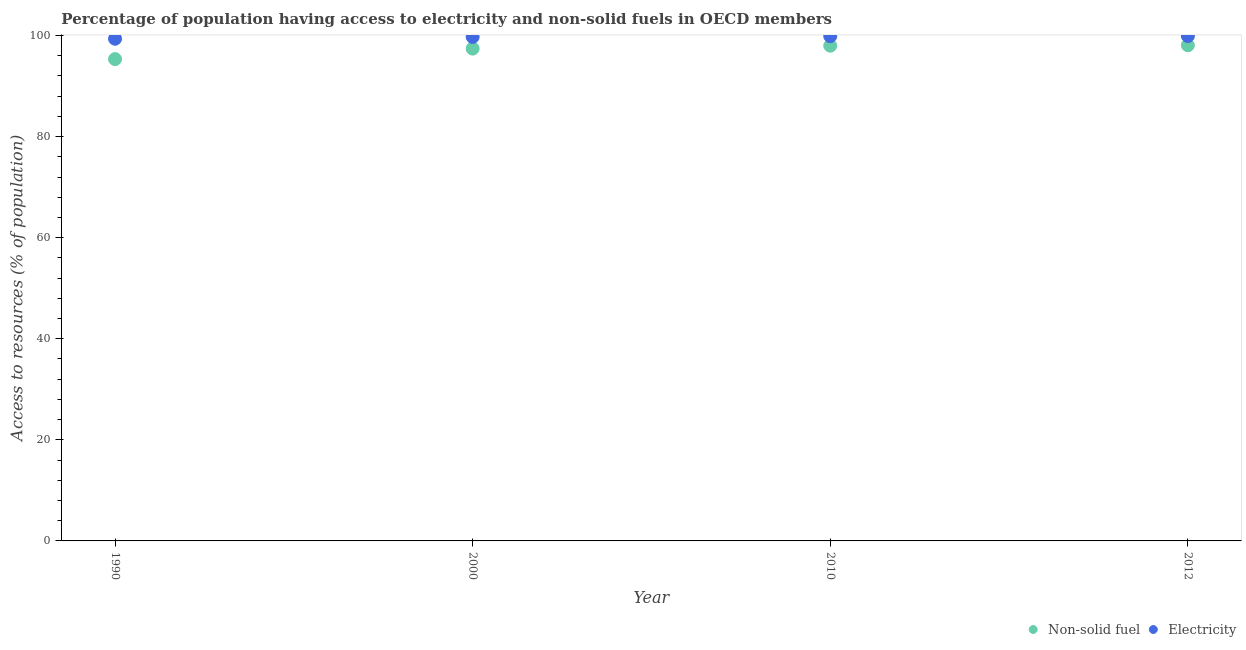What is the percentage of population having access to non-solid fuel in 2010?
Ensure brevity in your answer.  97.99. Across all years, what is the maximum percentage of population having access to electricity?
Give a very brief answer. 99.91. Across all years, what is the minimum percentage of population having access to electricity?
Provide a short and direct response. 99.37. In which year was the percentage of population having access to electricity maximum?
Your response must be concise. 2012. In which year was the percentage of population having access to non-solid fuel minimum?
Ensure brevity in your answer.  1990. What is the total percentage of population having access to non-solid fuel in the graph?
Your answer should be compact. 388.83. What is the difference between the percentage of population having access to electricity in 1990 and that in 2000?
Make the answer very short. -0.35. What is the difference between the percentage of population having access to non-solid fuel in 1990 and the percentage of population having access to electricity in 2000?
Keep it short and to the point. -4.38. What is the average percentage of population having access to non-solid fuel per year?
Your answer should be very brief. 97.21. In the year 2000, what is the difference between the percentage of population having access to non-solid fuel and percentage of population having access to electricity?
Your answer should be compact. -2.31. In how many years, is the percentage of population having access to electricity greater than 52 %?
Offer a very short reply. 4. What is the ratio of the percentage of population having access to electricity in 1990 to that in 2010?
Your response must be concise. 0.99. Is the percentage of population having access to non-solid fuel in 2000 less than that in 2012?
Offer a terse response. Yes. Is the difference between the percentage of population having access to electricity in 2010 and 2012 greater than the difference between the percentage of population having access to non-solid fuel in 2010 and 2012?
Ensure brevity in your answer.  Yes. What is the difference between the highest and the second highest percentage of population having access to non-solid fuel?
Keep it short and to the point. 0.08. What is the difference between the highest and the lowest percentage of population having access to non-solid fuel?
Ensure brevity in your answer.  2.73. Is the sum of the percentage of population having access to electricity in 1990 and 2010 greater than the maximum percentage of population having access to non-solid fuel across all years?
Give a very brief answer. Yes. Is the percentage of population having access to non-solid fuel strictly greater than the percentage of population having access to electricity over the years?
Give a very brief answer. No. Is the percentage of population having access to electricity strictly less than the percentage of population having access to non-solid fuel over the years?
Your answer should be very brief. No. How many dotlines are there?
Provide a succinct answer. 2. How many years are there in the graph?
Your answer should be compact. 4. What is the difference between two consecutive major ticks on the Y-axis?
Offer a terse response. 20. Does the graph contain any zero values?
Provide a succinct answer. No. Does the graph contain grids?
Make the answer very short. No. How many legend labels are there?
Your answer should be compact. 2. How are the legend labels stacked?
Offer a very short reply. Horizontal. What is the title of the graph?
Keep it short and to the point. Percentage of population having access to electricity and non-solid fuels in OECD members. What is the label or title of the Y-axis?
Offer a terse response. Access to resources (% of population). What is the Access to resources (% of population) of Non-solid fuel in 1990?
Provide a short and direct response. 95.34. What is the Access to resources (% of population) in Electricity in 1990?
Offer a very short reply. 99.37. What is the Access to resources (% of population) in Non-solid fuel in 2000?
Keep it short and to the point. 97.42. What is the Access to resources (% of population) in Electricity in 2000?
Give a very brief answer. 99.72. What is the Access to resources (% of population) of Non-solid fuel in 2010?
Give a very brief answer. 97.99. What is the Access to resources (% of population) in Electricity in 2010?
Your response must be concise. 99.88. What is the Access to resources (% of population) of Non-solid fuel in 2012?
Offer a terse response. 98.07. What is the Access to resources (% of population) in Electricity in 2012?
Ensure brevity in your answer.  99.91. Across all years, what is the maximum Access to resources (% of population) of Non-solid fuel?
Keep it short and to the point. 98.07. Across all years, what is the maximum Access to resources (% of population) in Electricity?
Keep it short and to the point. 99.91. Across all years, what is the minimum Access to resources (% of population) of Non-solid fuel?
Offer a terse response. 95.34. Across all years, what is the minimum Access to resources (% of population) in Electricity?
Ensure brevity in your answer.  99.37. What is the total Access to resources (% of population) in Non-solid fuel in the graph?
Make the answer very short. 388.83. What is the total Access to resources (% of population) in Electricity in the graph?
Provide a succinct answer. 398.88. What is the difference between the Access to resources (% of population) of Non-solid fuel in 1990 and that in 2000?
Your answer should be compact. -2.07. What is the difference between the Access to resources (% of population) in Electricity in 1990 and that in 2000?
Keep it short and to the point. -0.35. What is the difference between the Access to resources (% of population) in Non-solid fuel in 1990 and that in 2010?
Your answer should be compact. -2.65. What is the difference between the Access to resources (% of population) of Electricity in 1990 and that in 2010?
Your response must be concise. -0.51. What is the difference between the Access to resources (% of population) of Non-solid fuel in 1990 and that in 2012?
Your response must be concise. -2.73. What is the difference between the Access to resources (% of population) of Electricity in 1990 and that in 2012?
Keep it short and to the point. -0.54. What is the difference between the Access to resources (% of population) in Non-solid fuel in 2000 and that in 2010?
Offer a very short reply. -0.57. What is the difference between the Access to resources (% of population) in Electricity in 2000 and that in 2010?
Make the answer very short. -0.15. What is the difference between the Access to resources (% of population) in Non-solid fuel in 2000 and that in 2012?
Offer a terse response. -0.66. What is the difference between the Access to resources (% of population) of Electricity in 2000 and that in 2012?
Offer a very short reply. -0.18. What is the difference between the Access to resources (% of population) in Non-solid fuel in 2010 and that in 2012?
Provide a short and direct response. -0.08. What is the difference between the Access to resources (% of population) in Electricity in 2010 and that in 2012?
Provide a short and direct response. -0.03. What is the difference between the Access to resources (% of population) of Non-solid fuel in 1990 and the Access to resources (% of population) of Electricity in 2000?
Make the answer very short. -4.38. What is the difference between the Access to resources (% of population) in Non-solid fuel in 1990 and the Access to resources (% of population) in Electricity in 2010?
Offer a terse response. -4.54. What is the difference between the Access to resources (% of population) of Non-solid fuel in 1990 and the Access to resources (% of population) of Electricity in 2012?
Offer a terse response. -4.56. What is the difference between the Access to resources (% of population) of Non-solid fuel in 2000 and the Access to resources (% of population) of Electricity in 2010?
Provide a short and direct response. -2.46. What is the difference between the Access to resources (% of population) in Non-solid fuel in 2000 and the Access to resources (% of population) in Electricity in 2012?
Provide a short and direct response. -2.49. What is the difference between the Access to resources (% of population) in Non-solid fuel in 2010 and the Access to resources (% of population) in Electricity in 2012?
Offer a very short reply. -1.92. What is the average Access to resources (% of population) of Non-solid fuel per year?
Offer a terse response. 97.21. What is the average Access to resources (% of population) of Electricity per year?
Keep it short and to the point. 99.72. In the year 1990, what is the difference between the Access to resources (% of population) in Non-solid fuel and Access to resources (% of population) in Electricity?
Make the answer very short. -4.03. In the year 2000, what is the difference between the Access to resources (% of population) of Non-solid fuel and Access to resources (% of population) of Electricity?
Provide a short and direct response. -2.31. In the year 2010, what is the difference between the Access to resources (% of population) in Non-solid fuel and Access to resources (% of population) in Electricity?
Offer a terse response. -1.89. In the year 2012, what is the difference between the Access to resources (% of population) of Non-solid fuel and Access to resources (% of population) of Electricity?
Keep it short and to the point. -1.83. What is the ratio of the Access to resources (% of population) in Non-solid fuel in 1990 to that in 2000?
Provide a succinct answer. 0.98. What is the ratio of the Access to resources (% of population) in Electricity in 1990 to that in 2000?
Make the answer very short. 1. What is the ratio of the Access to resources (% of population) in Electricity in 1990 to that in 2010?
Offer a very short reply. 0.99. What is the ratio of the Access to resources (% of population) of Non-solid fuel in 1990 to that in 2012?
Your answer should be compact. 0.97. What is the ratio of the Access to resources (% of population) in Electricity in 2000 to that in 2010?
Offer a terse response. 1. What is the ratio of the Access to resources (% of population) in Non-solid fuel in 2000 to that in 2012?
Your answer should be compact. 0.99. What is the difference between the highest and the second highest Access to resources (% of population) in Non-solid fuel?
Offer a terse response. 0.08. What is the difference between the highest and the second highest Access to resources (% of population) of Electricity?
Your answer should be very brief. 0.03. What is the difference between the highest and the lowest Access to resources (% of population) of Non-solid fuel?
Provide a short and direct response. 2.73. What is the difference between the highest and the lowest Access to resources (% of population) of Electricity?
Ensure brevity in your answer.  0.54. 